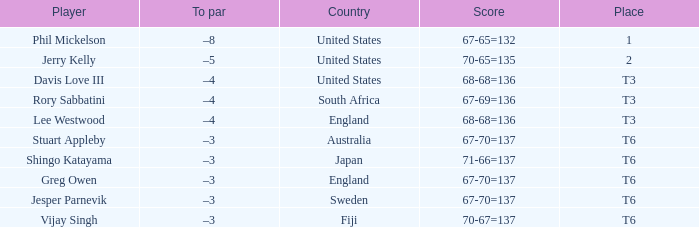Name the place for score of 67-70=137 and stuart appleby T6. 